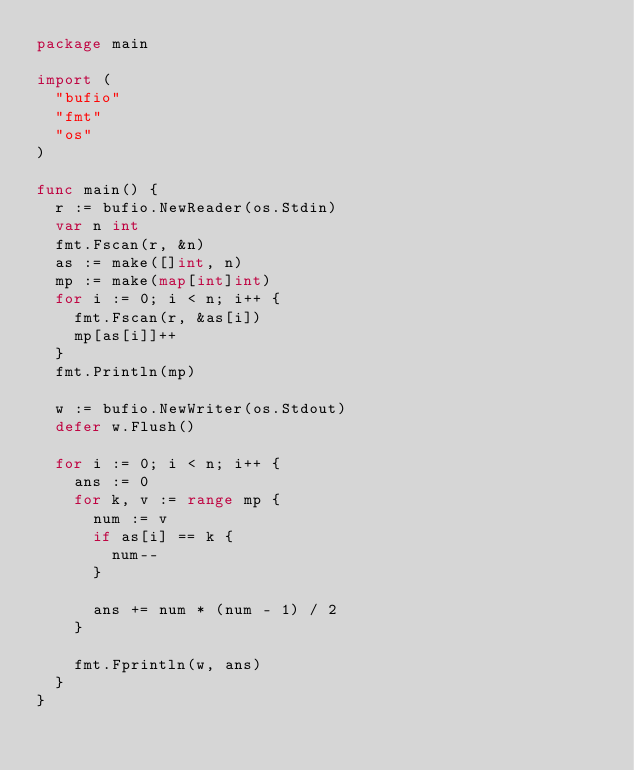Convert code to text. <code><loc_0><loc_0><loc_500><loc_500><_Go_>package main

import (
	"bufio"
	"fmt"
	"os"
)

func main() {
	r := bufio.NewReader(os.Stdin)
	var n int
	fmt.Fscan(r, &n)
	as := make([]int, n)
	mp := make(map[int]int)
	for i := 0; i < n; i++ {
		fmt.Fscan(r, &as[i])
		mp[as[i]]++
	}
	fmt.Println(mp)

	w := bufio.NewWriter(os.Stdout)
	defer w.Flush()

	for i := 0; i < n; i++ {
		ans := 0
		for k, v := range mp {
			num := v
			if as[i] == k {
				num--
			}

			ans += num * (num - 1) / 2
		}

		fmt.Fprintln(w, ans)
	}
}
</code> 